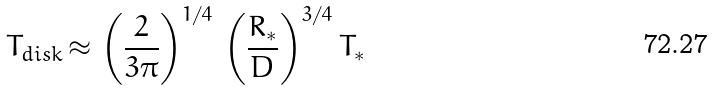Convert formula to latex. <formula><loc_0><loc_0><loc_500><loc_500>T _ { d i s k } \, { \approx } \, \left ( \frac { 2 } { 3 { \pi } } \right ) ^ { 1 / 4 } \, \left ( \frac { R _ { * } } { D } \right ) ^ { 3 / 4 } T _ { * }</formula> 